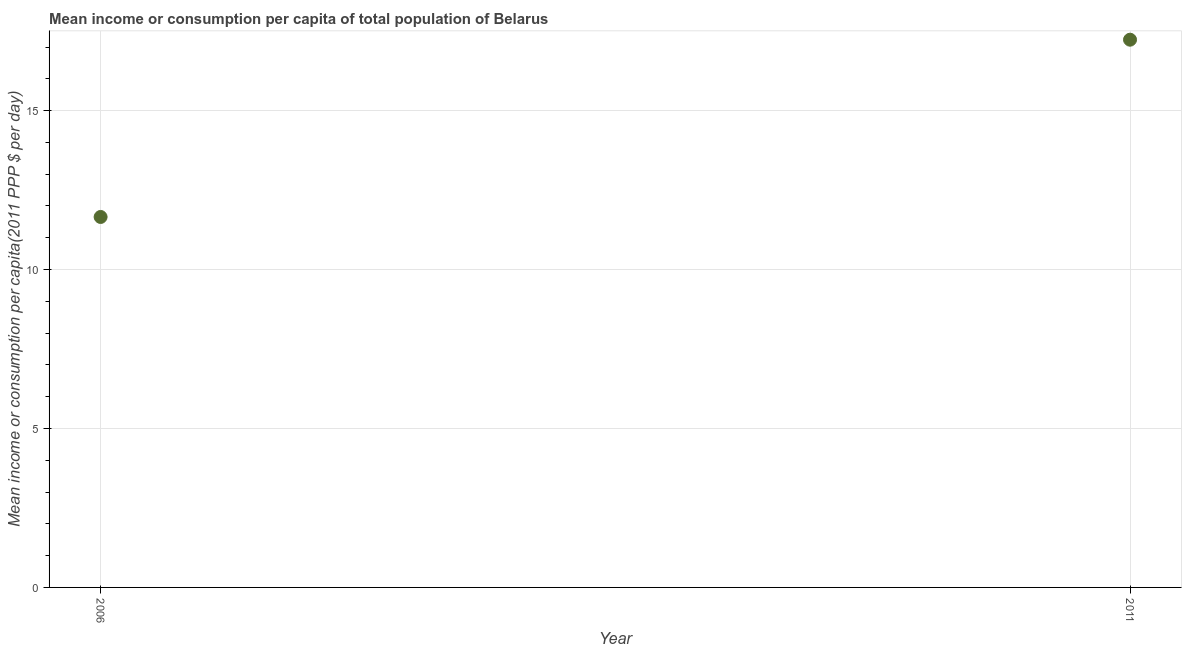What is the mean income or consumption in 2006?
Offer a terse response. 11.65. Across all years, what is the maximum mean income or consumption?
Your answer should be compact. 17.23. Across all years, what is the minimum mean income or consumption?
Keep it short and to the point. 11.65. In which year was the mean income or consumption minimum?
Your answer should be compact. 2006. What is the sum of the mean income or consumption?
Your response must be concise. 28.88. What is the difference between the mean income or consumption in 2006 and 2011?
Offer a terse response. -5.58. What is the average mean income or consumption per year?
Offer a very short reply. 14.44. What is the median mean income or consumption?
Keep it short and to the point. 14.44. In how many years, is the mean income or consumption greater than 14 $?
Provide a short and direct response. 1. Do a majority of the years between 2006 and 2011 (inclusive) have mean income or consumption greater than 11 $?
Ensure brevity in your answer.  Yes. What is the ratio of the mean income or consumption in 2006 to that in 2011?
Your answer should be compact. 0.68. How many dotlines are there?
Keep it short and to the point. 1. How many years are there in the graph?
Make the answer very short. 2. What is the difference between two consecutive major ticks on the Y-axis?
Give a very brief answer. 5. Are the values on the major ticks of Y-axis written in scientific E-notation?
Offer a very short reply. No. Does the graph contain any zero values?
Provide a succinct answer. No. Does the graph contain grids?
Offer a very short reply. Yes. What is the title of the graph?
Your answer should be compact. Mean income or consumption per capita of total population of Belarus. What is the label or title of the X-axis?
Keep it short and to the point. Year. What is the label or title of the Y-axis?
Give a very brief answer. Mean income or consumption per capita(2011 PPP $ per day). What is the Mean income or consumption per capita(2011 PPP $ per day) in 2006?
Make the answer very short. 11.65. What is the Mean income or consumption per capita(2011 PPP $ per day) in 2011?
Give a very brief answer. 17.23. What is the difference between the Mean income or consumption per capita(2011 PPP $ per day) in 2006 and 2011?
Provide a short and direct response. -5.58. What is the ratio of the Mean income or consumption per capita(2011 PPP $ per day) in 2006 to that in 2011?
Make the answer very short. 0.68. 